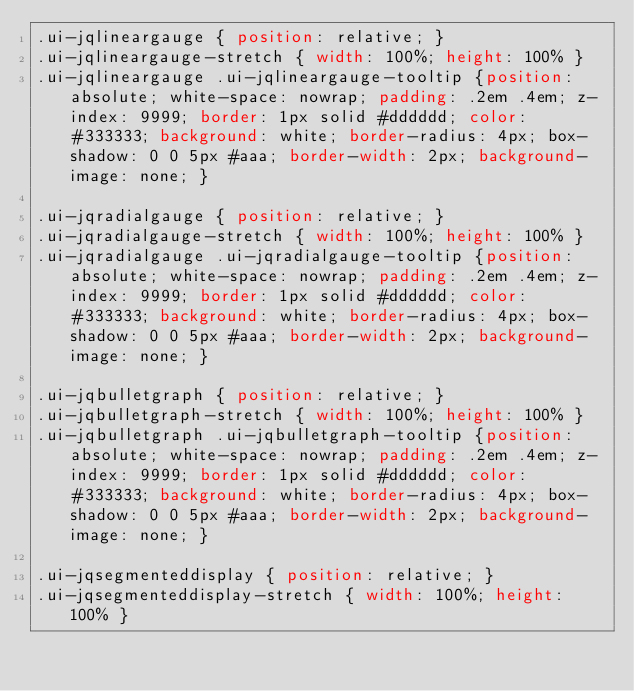<code> <loc_0><loc_0><loc_500><loc_500><_CSS_>.ui-jqlineargauge { position: relative; }
.ui-jqlineargauge-stretch { width: 100%; height: 100% }
.ui-jqlineargauge .ui-jqlineargauge-tooltip {position: absolute; white-space: nowrap; padding: .2em .4em; z-index: 9999; border: 1px solid #dddddd; color: #333333; background: white; border-radius: 4px; box-shadow: 0 0 5px #aaa; border-width: 2px; background-image: none; }

.ui-jqradialgauge { position: relative; }
.ui-jqradialgauge-stretch { width: 100%; height: 100% }
.ui-jqradialgauge .ui-jqradialgauge-tooltip {position: absolute; white-space: nowrap; padding: .2em .4em; z-index: 9999; border: 1px solid #dddddd; color: #333333; background: white; border-radius: 4px; box-shadow: 0 0 5px #aaa; border-width: 2px; background-image: none; }

.ui-jqbulletgraph { position: relative; }
.ui-jqbulletgraph-stretch { width: 100%; height: 100% }
.ui-jqbulletgraph .ui-jqbulletgraph-tooltip {position: absolute; white-space: nowrap; padding: .2em .4em; z-index: 9999; border: 1px solid #dddddd; color: #333333; background: white; border-radius: 4px; box-shadow: 0 0 5px #aaa; border-width: 2px; background-image: none; }

.ui-jqsegmenteddisplay { position: relative; }
.ui-jqsegmenteddisplay-stretch { width: 100%; height: 100% }

</code> 